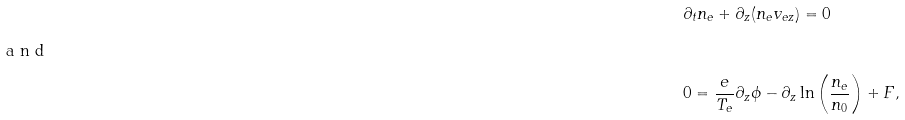Convert formula to latex. <formula><loc_0><loc_0><loc_500><loc_500>& \partial _ { t } n _ { e } + \partial _ { z } ( n _ { e } v _ { e z } ) = 0 \intertext { a n d } & 0 = \frac { e } { T _ { e } } \partial _ { z } \phi - \partial _ { z } \ln \left ( \frac { n _ { e } } { n _ { 0 } } \right ) + F ,</formula> 